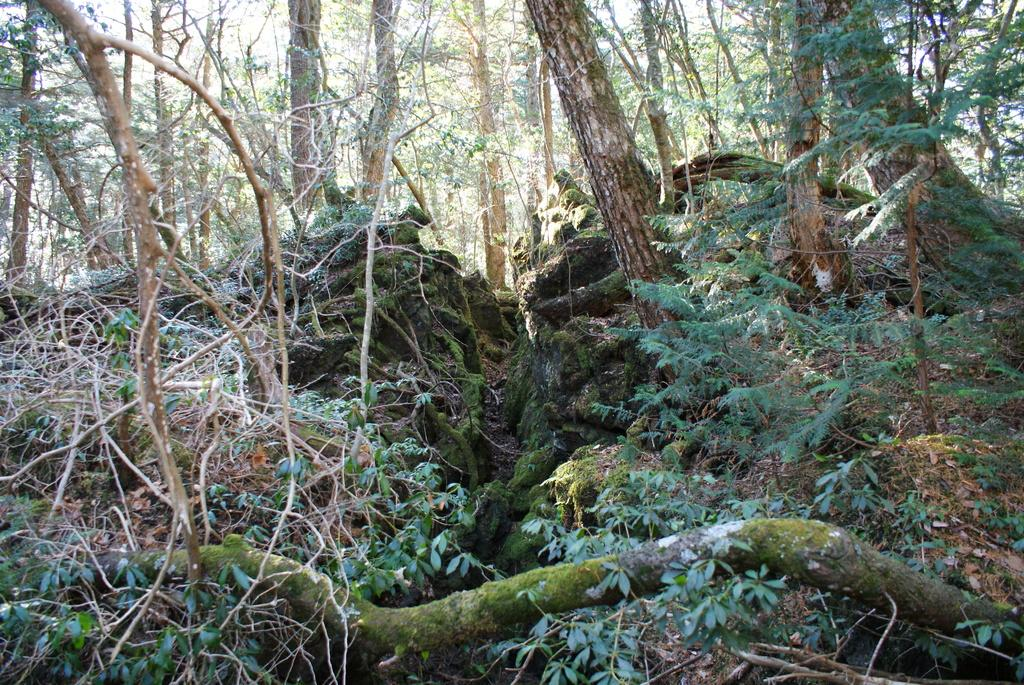What type of vegetation can be seen in the image? There are trees and plants in the image. What is visible at the top of the image? The sky is visible at the top of the image. Can you describe any other features at the bottom of the image? There might be roots visible at the bottom of the image. What type of butter can be seen on the window in the image? There is no butter or window present in the image; it features trees, plants, and the sky. How does the bomb affect the trees in the image? There is no bomb present in the image, so it cannot affect the trees. 